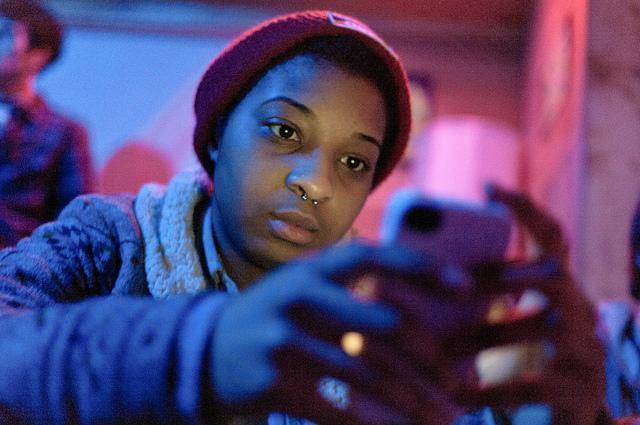How many cell phones are visible?
Give a very brief answer. 1. How many people are there?
Give a very brief answer. 2. How many black motorcycles are there?
Give a very brief answer. 0. 